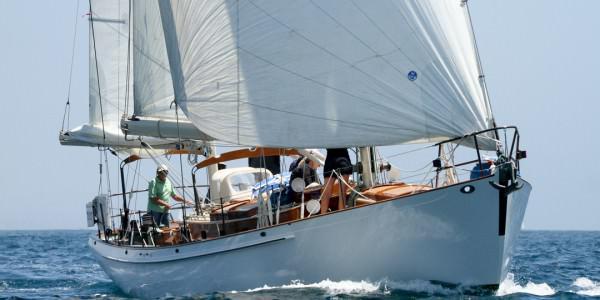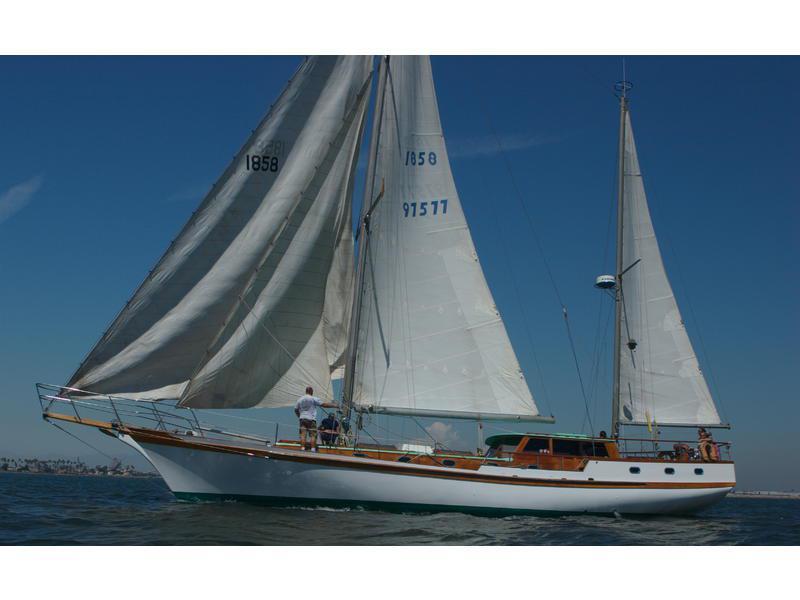The first image is the image on the left, the second image is the image on the right. Evaluate the accuracy of this statement regarding the images: "The left and right image contains a total of seven open sails.". Is it true? Answer yes or no. Yes. The first image is the image on the left, the second image is the image on the right. Considering the images on both sides, is "The boat in the right image has exactly four sails." valid? Answer yes or no. Yes. 